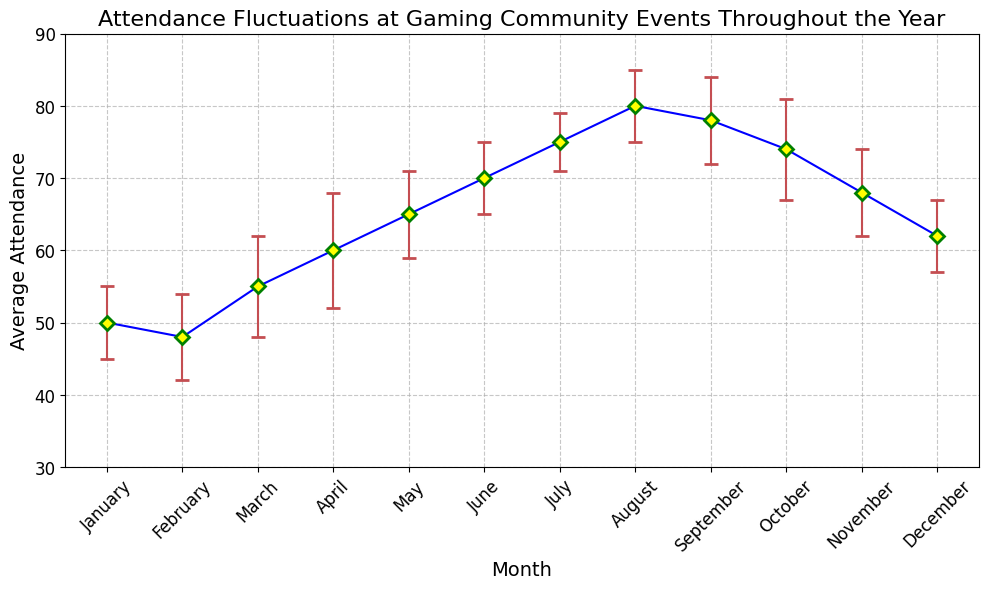Which month has the highest average attendance? The highest average attendance can be identified by looking for the peak point in the average attendance data. August has the highest point at 80.
Answer: August Which month has the lowest average attendance? The lowest average attendance can be spotted by looking for the lowest point in the average attendance data. February has the lowest point at 48.
Answer: February Compare the average attendance in July and November. Which one is higher? To determine which month has a higher average attendance, compare the markers for July and November. July has an average attendance of 75, while November has 68. Therefore, July is higher.
Answer: July What is the difference in average attendance between May and October? To find the difference, subtract the average attendance in October from that in May. May has an average attendance of 65, and October has 74. So the difference is 74 - 65 = 9.
Answer: 9 If you sum the average attendance of January, February, and March, how much would it be? Add the average attendance for these three months: January (50), February (48), and March (55). The total is 50 + 48 + 55 = 153.
Answer: 153 Which month shows a smaller variability in attendance: June or September? Smaller variability can be determined by comparing the standard deviations. June has a standard deviation of 5, while September has a standard deviation of 6. Therefore, June has smaller variability.
Answer: June What is the error range (average attendance ± standard deviation) for December? The error range is calculated by adding and subtracting the standard deviation from the average attendance for December. December has an average attendance of 62 and a standard deviation of 5. The range is 62 ± 5, thus it ranges from 57 to 67.
Answer: 57 to 67 Does August have more or less variability in attendance compared to January? Compare the standard deviations of August and January. August has a standard deviation of 5, while January has a standard deviation of 5 as well, meaning both have equal variability.
Answer: equal Which three consecutive months have the highest total average attendance? To find this, calculate the sum of average attendance for every three consecutive months and identify the highest sum. The highest total is for June, July, and August: 70 + 75 + 80 = 225.
Answer: June, July, August What is the average attendance in June? Locate the point representing June and read the average attendance value. June has an average attendance of 70.
Answer: 70 